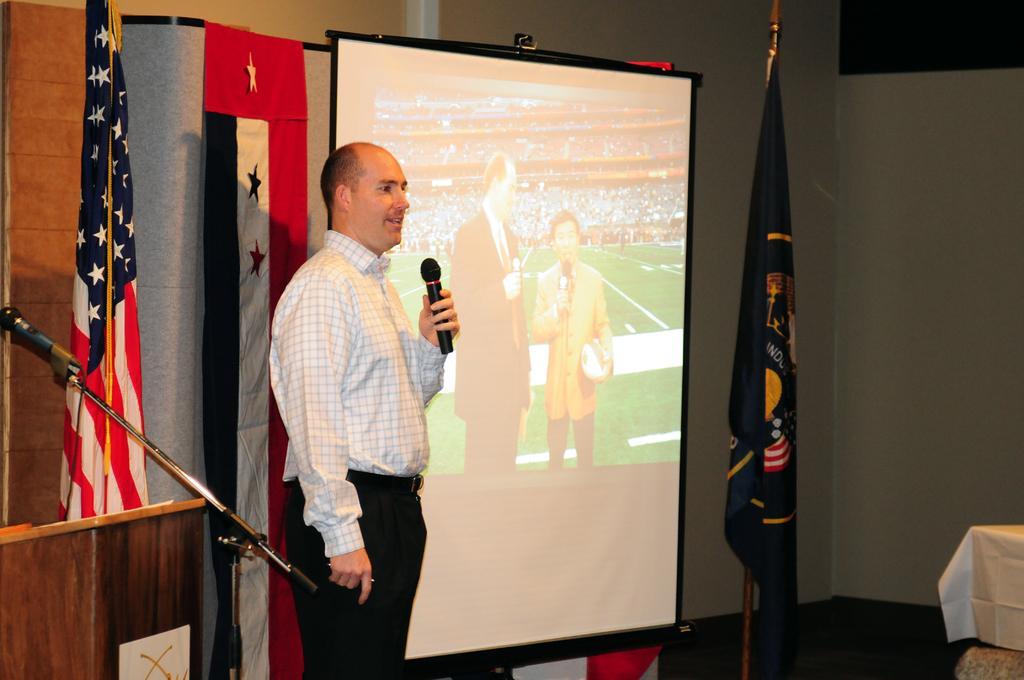Can you describe this image briefly? In this image there is a person standing and holding an object, there is a screen, there are flags, there is a microphone, there is a stand, there is an object truncated towards the left of the image, there is an object truncated towards the right of the image, there is a wall. 